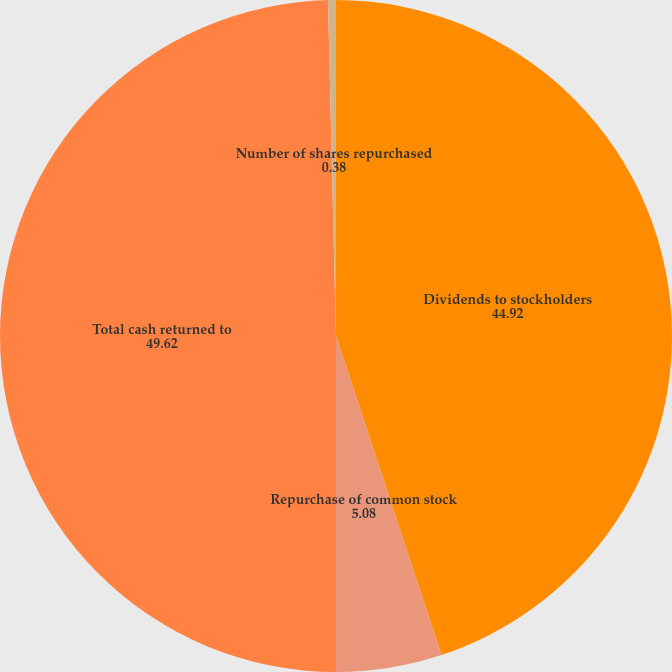Convert chart. <chart><loc_0><loc_0><loc_500><loc_500><pie_chart><fcel>Dividends to stockholders<fcel>Repurchase of common stock<fcel>Total cash returned to<fcel>Number of shares repurchased<nl><fcel>44.92%<fcel>5.08%<fcel>49.62%<fcel>0.38%<nl></chart> 